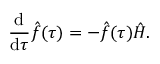<formula> <loc_0><loc_0><loc_500><loc_500>\frac { d } { d \tau } \hat { f } ( \tau ) = - \hat { f } ( \tau ) \hat { H } .</formula> 